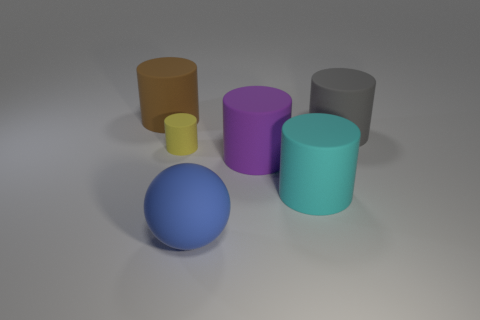What size is the rubber cylinder that is both left of the cyan cylinder and behind the yellow matte thing?
Ensure brevity in your answer.  Large. Is the shape of the brown rubber object the same as the big rubber object that is to the right of the cyan matte object?
Provide a short and direct response. Yes. There is a gray matte object that is the same shape as the big brown matte thing; what is its size?
Keep it short and to the point. Large. Is the color of the tiny rubber thing the same as the large cylinder that is right of the large cyan object?
Your response must be concise. No. What number of other things are the same size as the yellow thing?
Provide a succinct answer. 0. The big object behind the thing that is to the right of the cylinder in front of the purple rubber thing is what shape?
Ensure brevity in your answer.  Cylinder. Do the gray cylinder and the rubber object that is to the left of the small yellow rubber object have the same size?
Offer a terse response. Yes. What is the color of the big matte cylinder that is to the right of the blue thing and behind the purple object?
Your answer should be very brief. Gray. What number of other objects are the same shape as the tiny yellow thing?
Ensure brevity in your answer.  4. There is a big rubber cylinder to the left of the large matte sphere; is its color the same as the cylinder that is in front of the purple cylinder?
Give a very brief answer. No. 